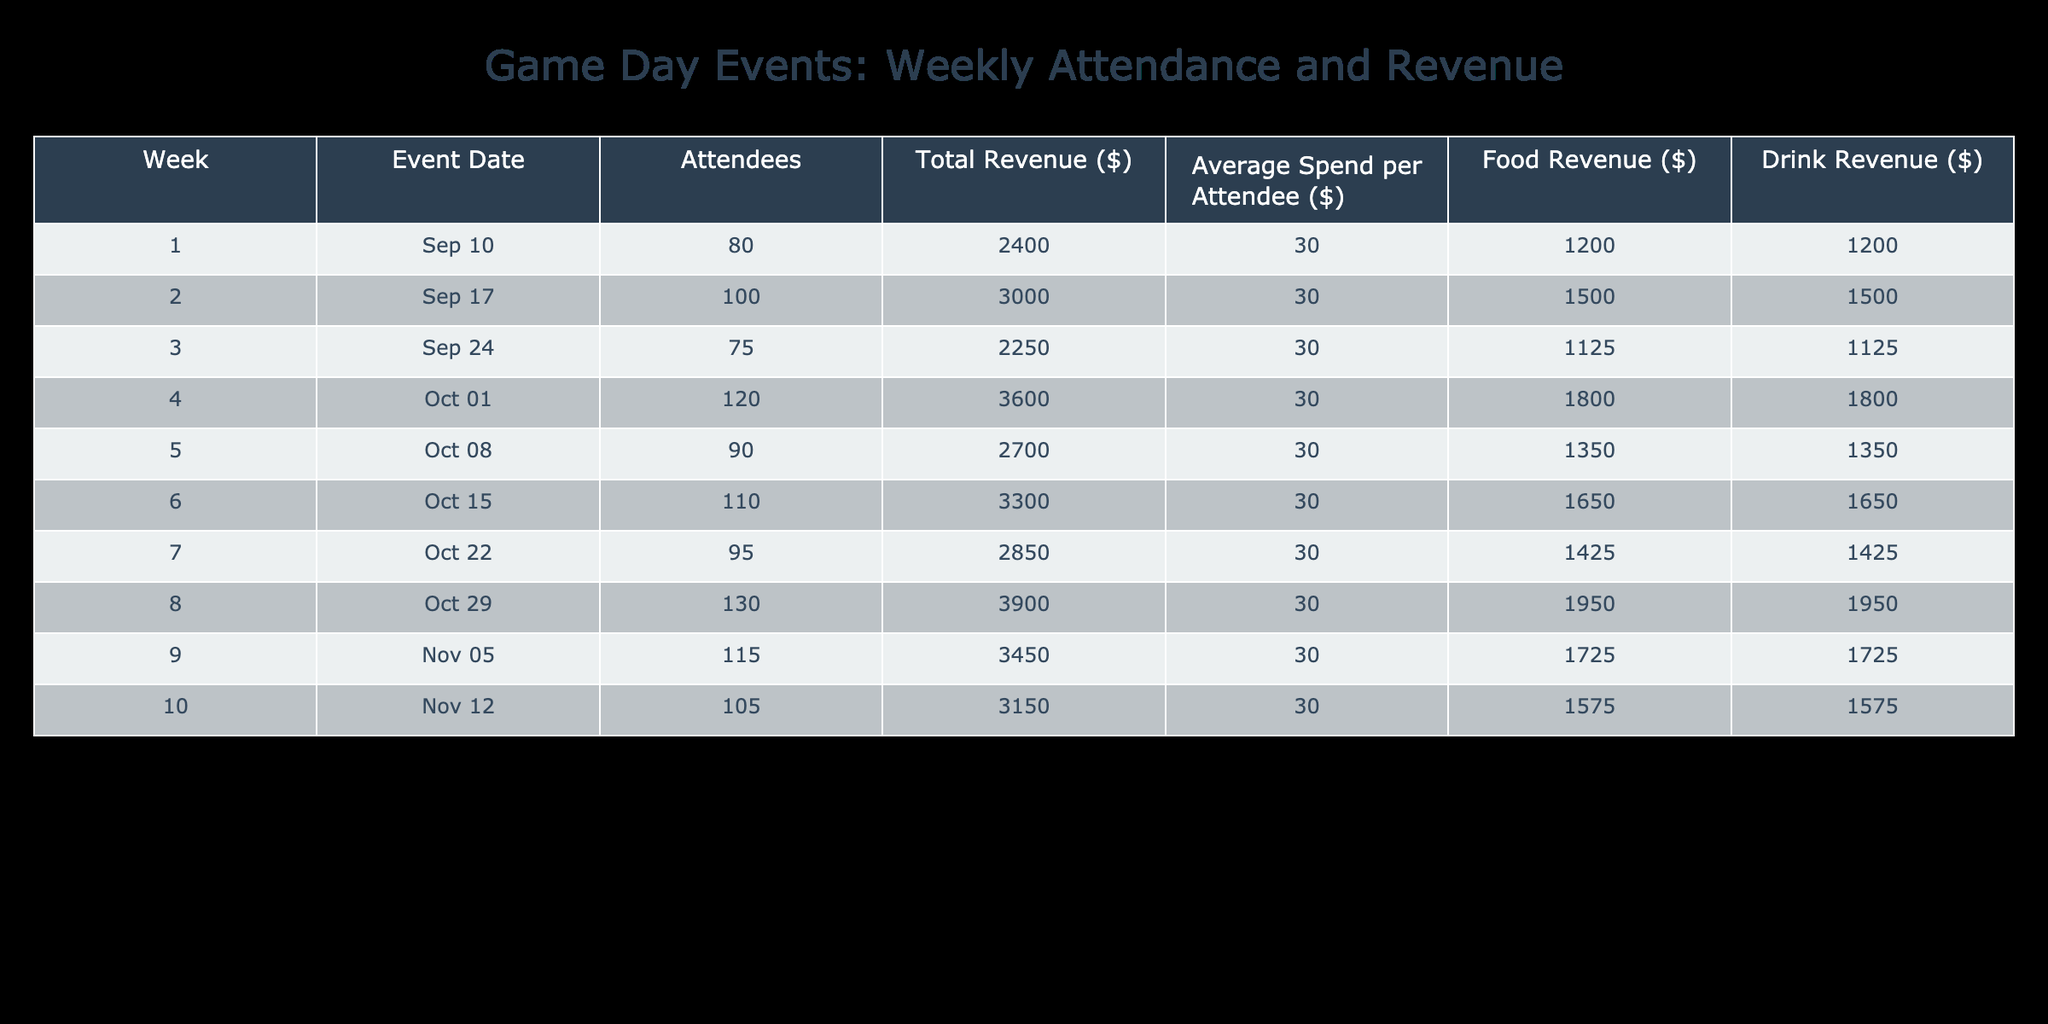What week had the highest number of attendees? Looking at the "Attendees" column, the maximum value is 130, which corresponds to Week 8 (2023-10-29).
Answer: Week 8 What was the total revenue for Week 6? In the "Total Revenue ($)" column, the value for Week 6 is directly listed as 3300.
Answer: 3300 What is the average attendance across all weeks? The total number of attendees across all weeks is (80 + 100 + 75 + 120 + 90 + 110 + 95 + 130 + 115 + 105) = 1000. There are 10 weeks, so the average attendance is 1000 / 10 = 100.
Answer: 100 Was the average spend per attendee consistent throughout all weeks? All values in the "Average Spend per Attendee ($)" column are the same at 30, indicating consistency.
Answer: Yes Which week generated the highest food revenue? The highest value in the "Food Revenue ($)" column is 1950 for Week 8 (2023-10-29).
Answer: Week 8 What is the difference in total revenue between Week 4 and Week 3? The total revenue for Week 4 is 3600 and for Week 3 is 2250. The difference is 3600 - 2250 = 1350.
Answer: 1350 How many weeks had more than 100 attendees? Referring to the "Attendees" column, Weeks 2, 4, 6, 8, and 9 all had more than 100 attendees, which counts for 5 weeks.
Answer: 5 weeks What is the median drink revenue across all weeks? The "Drink Revenue ($)" values are: [1200, 1500, 1125, 1800, 1350, 1650, 1425, 1950, 1725, 1575]. Arranging these values in ascending order gives us [1125, 1200, 1350, 1425, 1500, 1575, 1650, 1725, 1800, 1950]. The median is the average of the 5th and 6th values: (1500 + 1575) / 2 = 1537.5.
Answer: 1537.5 Which week had the lowest drink revenue? The minimum value in the "Drink Revenue ($)" column is 1125 for Week 3 (2023-09-24).
Answer: Week 3 